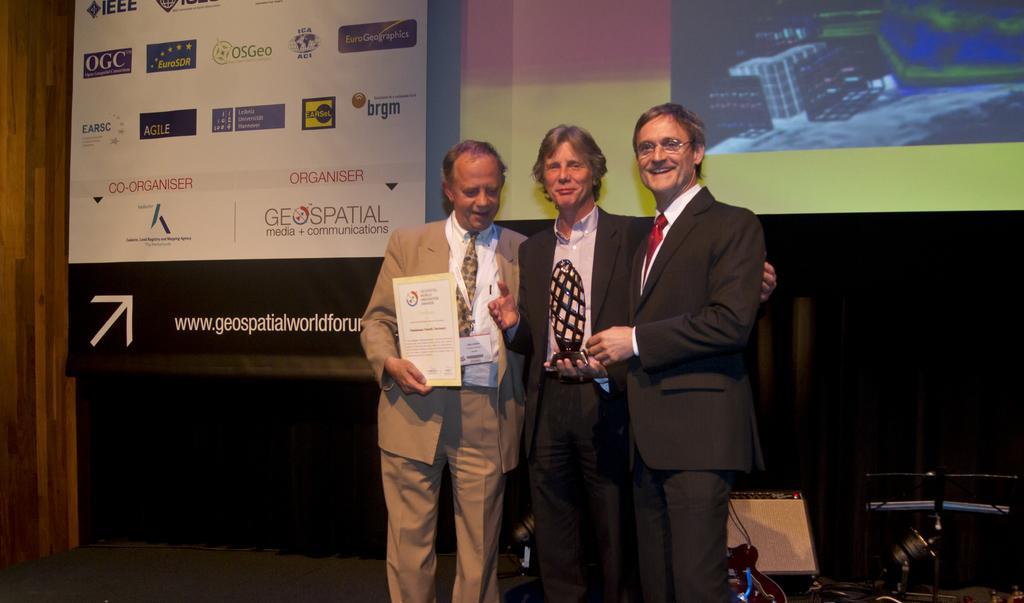Could you give a brief overview of what you see in this image? In this picture we can see three people standing and smiling. Out of three people, we can see two people holding objects in their hands. There is the text and a few things visible on a board. We can see a screen and other objects. 